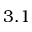Convert formula to latex. <formula><loc_0><loc_0><loc_500><loc_500>3 . 1</formula> 